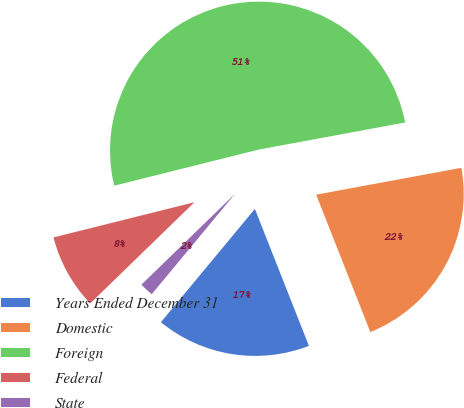Convert chart to OTSL. <chart><loc_0><loc_0><loc_500><loc_500><pie_chart><fcel>Years Ended December 31<fcel>Domestic<fcel>Foreign<fcel>Federal<fcel>State<nl><fcel>17.0%<fcel>21.93%<fcel>50.98%<fcel>8.37%<fcel>1.71%<nl></chart> 